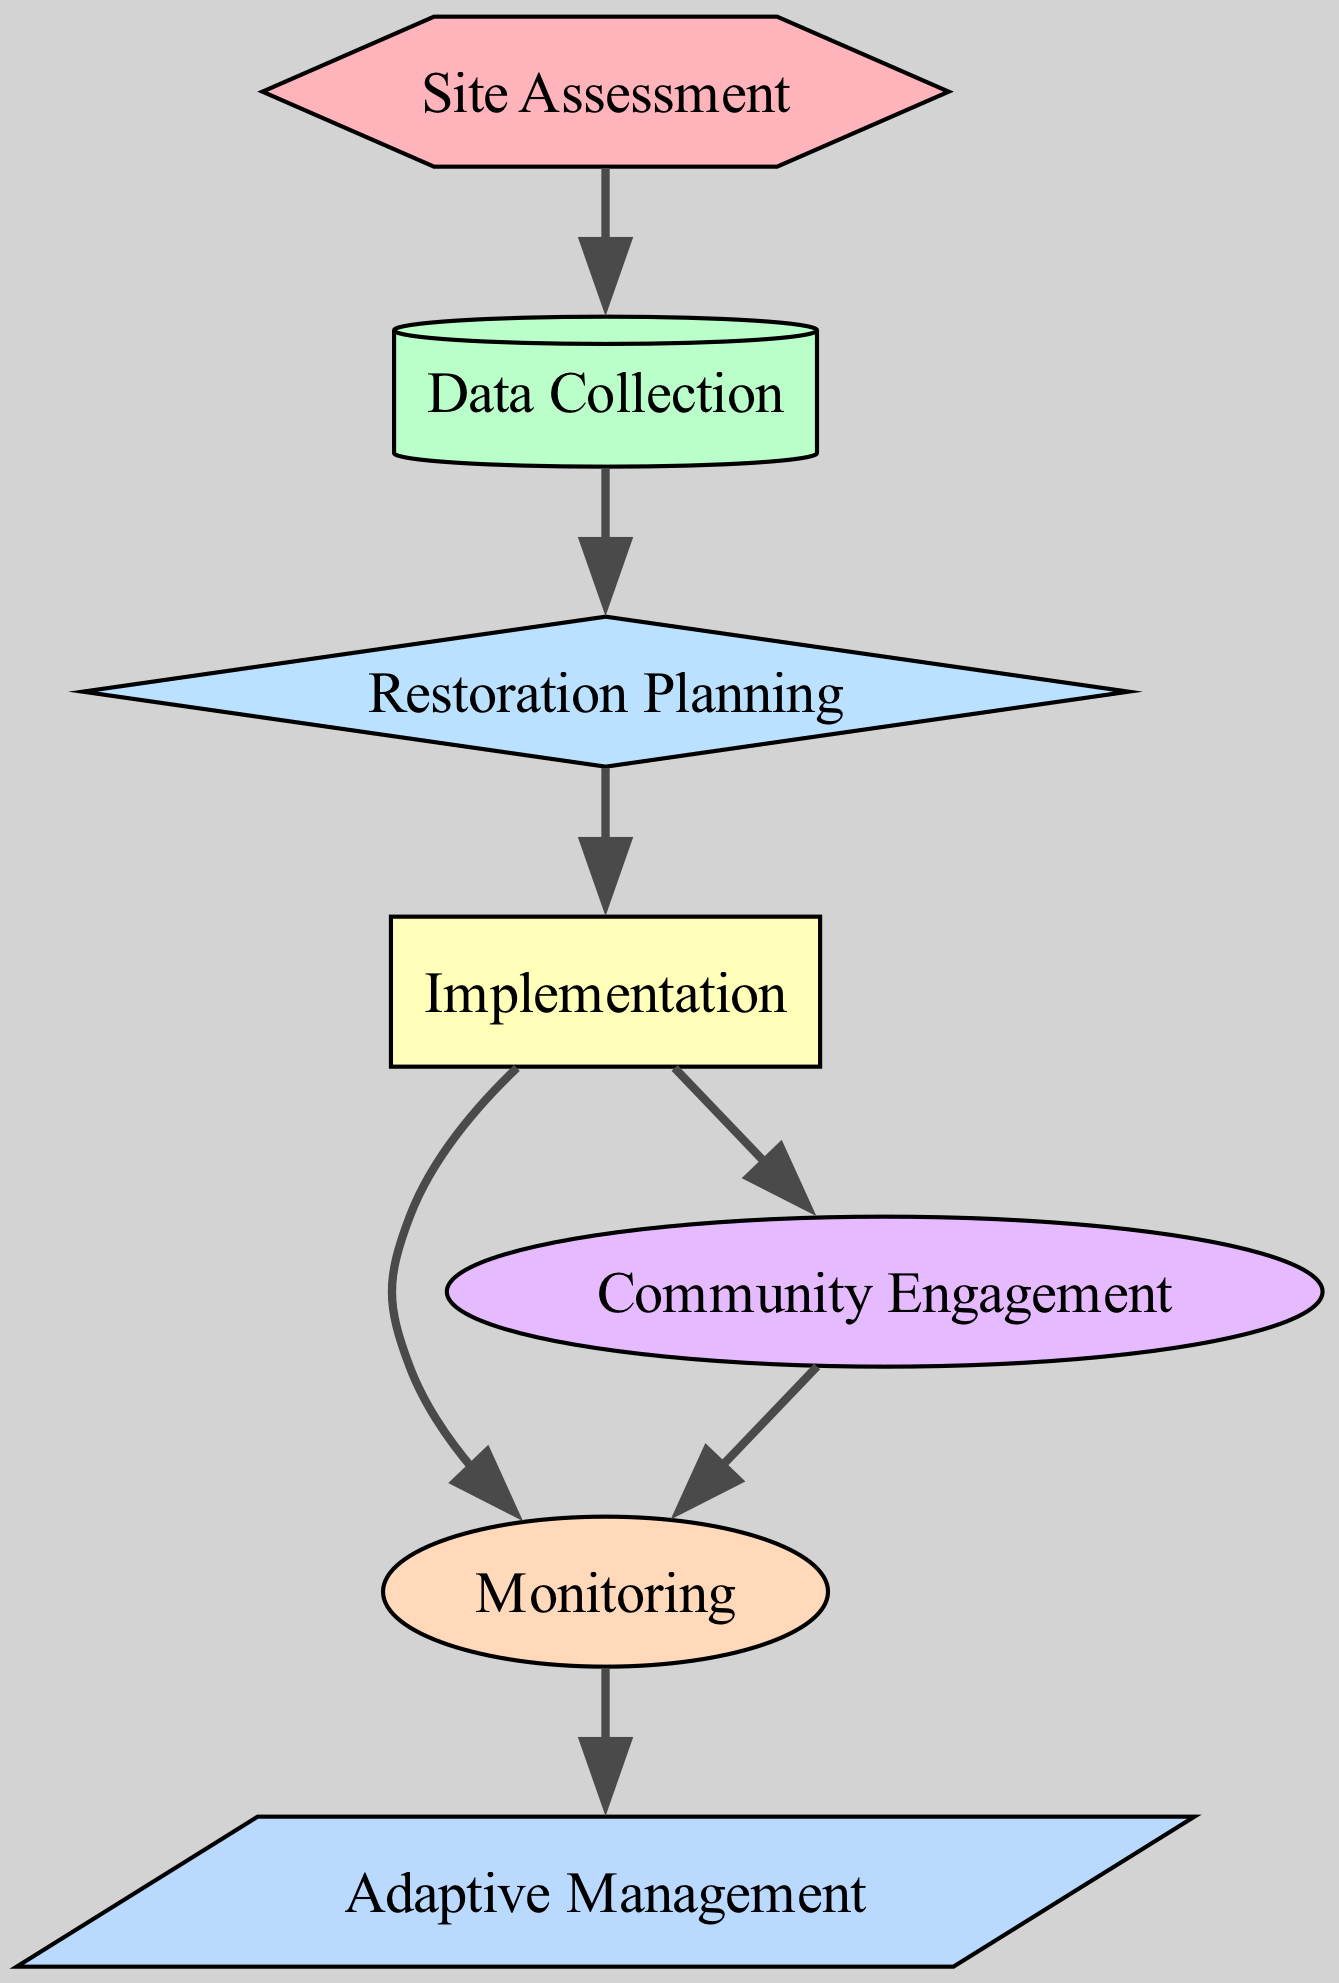What is the first stage in the ecological restoration process? The first stage in the diagram is "Site Assessment," which is the initial step before any data collection or planning can occur.
Answer: Site Assessment How many nodes are present in the diagram? Counting all the nodes listed in the diagram, there are a total of seven nodes representing different stages in the ecological restoration process.
Answer: 7 What node follows "Data Collection" in the process? In the directed graph, "Restoration Planning" directly follows "Data Collection," indicating the next step after collecting data.
Answer: Restoration Planning Which node is connected to both "Implementation" and "Monitoring"? The node "Community Engagement" is connected to "Implementation" and also leads to "Monitoring," suggesting its importance at both stages.
Answer: Community Engagement What is the last stage in the ecological restoration process? The last stage in the directed graph is "Adaptive Management," which follows "Monitoring" as the concluding phase to ensure ongoing adjustments and improvements.
Answer: Adaptive Management How many edges connect the nodes in the diagram? By counting all the edges defined in the diagram, there are a total of six connections that represent the flow from one process to the next.
Answer: 6 Which two nodes require the completion of "Implementation" before they can be reached? "Monitoring" and "Community Engagement" both require the completion of "Implementation" before advancing, as indicated by the directed edges in the diagram.
Answer: Monitoring and Community Engagement Which node follows "Monitoring" and is part of the adaptive management process? The node that follows "Monitoring" in the directed graph is "Adaptive Management," highlighting its role in adjusting strategies based on monitoring results.
Answer: Adaptive Management What is the relationship between "Restoration Planning" and "Implementation"? "Restoration Planning" must be completed before moving into the "Implementation" stage, reflecting the sequential nature of the restoration process as depicted by the directed edge.
Answer: Sequential relationship 